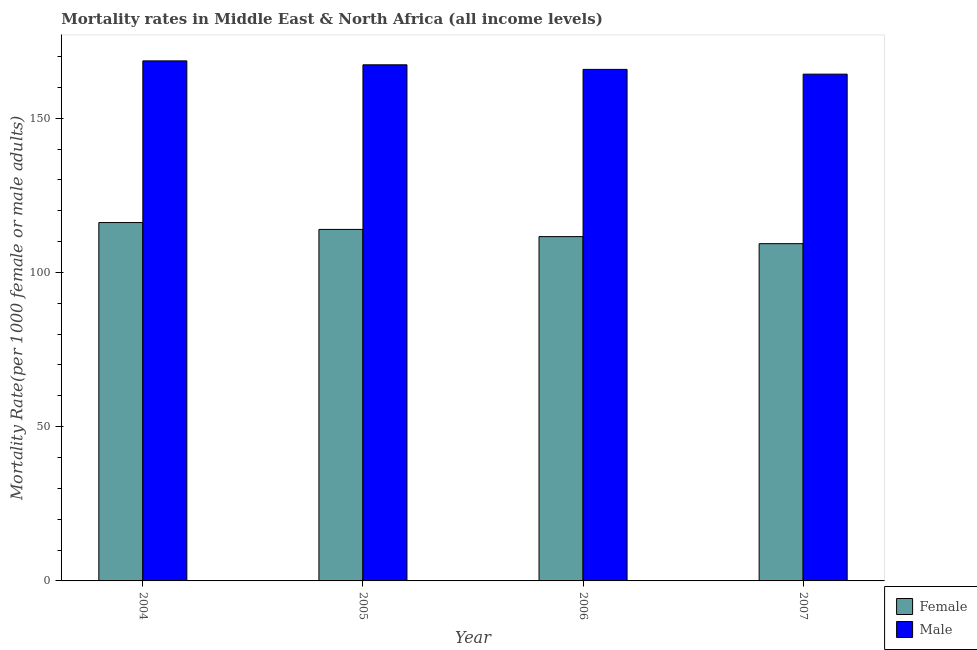How many bars are there on the 4th tick from the left?
Keep it short and to the point. 2. How many bars are there on the 3rd tick from the right?
Keep it short and to the point. 2. What is the male mortality rate in 2004?
Your answer should be compact. 168.58. Across all years, what is the maximum female mortality rate?
Make the answer very short. 116.17. Across all years, what is the minimum male mortality rate?
Offer a very short reply. 164.28. In which year was the female mortality rate maximum?
Provide a short and direct response. 2004. In which year was the male mortality rate minimum?
Your response must be concise. 2007. What is the total female mortality rate in the graph?
Your answer should be very brief. 451.04. What is the difference between the female mortality rate in 2004 and that in 2007?
Keep it short and to the point. 6.84. What is the difference between the male mortality rate in 2005 and the female mortality rate in 2004?
Keep it short and to the point. -1.27. What is the average female mortality rate per year?
Give a very brief answer. 112.76. In the year 2005, what is the difference between the female mortality rate and male mortality rate?
Your response must be concise. 0. In how many years, is the female mortality rate greater than 30?
Your answer should be compact. 4. What is the ratio of the female mortality rate in 2004 to that in 2005?
Make the answer very short. 1.02. Is the male mortality rate in 2005 less than that in 2007?
Ensure brevity in your answer.  No. Is the difference between the female mortality rate in 2005 and 2007 greater than the difference between the male mortality rate in 2005 and 2007?
Make the answer very short. No. What is the difference between the highest and the second highest female mortality rate?
Provide a succinct answer. 2.22. What is the difference between the highest and the lowest female mortality rate?
Your response must be concise. 6.84. Is the sum of the male mortality rate in 2006 and 2007 greater than the maximum female mortality rate across all years?
Make the answer very short. Yes. What does the 1st bar from the left in 2005 represents?
Your response must be concise. Female. What does the 1st bar from the right in 2006 represents?
Your answer should be compact. Male. How many bars are there?
Your response must be concise. 8. Are all the bars in the graph horizontal?
Provide a short and direct response. No. How many years are there in the graph?
Offer a terse response. 4. What is the difference between two consecutive major ticks on the Y-axis?
Offer a very short reply. 50. Are the values on the major ticks of Y-axis written in scientific E-notation?
Your answer should be very brief. No. Does the graph contain grids?
Keep it short and to the point. No. What is the title of the graph?
Offer a terse response. Mortality rates in Middle East & North Africa (all income levels). What is the label or title of the Y-axis?
Offer a terse response. Mortality Rate(per 1000 female or male adults). What is the Mortality Rate(per 1000 female or male adults) in Female in 2004?
Offer a terse response. 116.17. What is the Mortality Rate(per 1000 female or male adults) of Male in 2004?
Your answer should be compact. 168.58. What is the Mortality Rate(per 1000 female or male adults) in Female in 2005?
Offer a terse response. 113.94. What is the Mortality Rate(per 1000 female or male adults) in Male in 2005?
Offer a very short reply. 167.3. What is the Mortality Rate(per 1000 female or male adults) of Female in 2006?
Your answer should be compact. 111.61. What is the Mortality Rate(per 1000 female or male adults) in Male in 2006?
Your response must be concise. 165.82. What is the Mortality Rate(per 1000 female or male adults) in Female in 2007?
Give a very brief answer. 109.32. What is the Mortality Rate(per 1000 female or male adults) in Male in 2007?
Keep it short and to the point. 164.28. Across all years, what is the maximum Mortality Rate(per 1000 female or male adults) in Female?
Provide a short and direct response. 116.17. Across all years, what is the maximum Mortality Rate(per 1000 female or male adults) of Male?
Your response must be concise. 168.58. Across all years, what is the minimum Mortality Rate(per 1000 female or male adults) of Female?
Give a very brief answer. 109.32. Across all years, what is the minimum Mortality Rate(per 1000 female or male adults) in Male?
Your answer should be compact. 164.28. What is the total Mortality Rate(per 1000 female or male adults) of Female in the graph?
Your answer should be very brief. 451.04. What is the total Mortality Rate(per 1000 female or male adults) in Male in the graph?
Keep it short and to the point. 665.98. What is the difference between the Mortality Rate(per 1000 female or male adults) in Female in 2004 and that in 2005?
Give a very brief answer. 2.22. What is the difference between the Mortality Rate(per 1000 female or male adults) in Male in 2004 and that in 2005?
Your answer should be compact. 1.27. What is the difference between the Mortality Rate(per 1000 female or male adults) in Female in 2004 and that in 2006?
Ensure brevity in your answer.  4.56. What is the difference between the Mortality Rate(per 1000 female or male adults) of Male in 2004 and that in 2006?
Provide a short and direct response. 2.76. What is the difference between the Mortality Rate(per 1000 female or male adults) of Female in 2004 and that in 2007?
Your response must be concise. 6.84. What is the difference between the Mortality Rate(per 1000 female or male adults) of Male in 2004 and that in 2007?
Offer a very short reply. 4.3. What is the difference between the Mortality Rate(per 1000 female or male adults) of Female in 2005 and that in 2006?
Your answer should be compact. 2.33. What is the difference between the Mortality Rate(per 1000 female or male adults) of Male in 2005 and that in 2006?
Keep it short and to the point. 1.49. What is the difference between the Mortality Rate(per 1000 female or male adults) in Female in 2005 and that in 2007?
Your answer should be very brief. 4.62. What is the difference between the Mortality Rate(per 1000 female or male adults) in Male in 2005 and that in 2007?
Provide a succinct answer. 3.03. What is the difference between the Mortality Rate(per 1000 female or male adults) in Female in 2006 and that in 2007?
Your response must be concise. 2.29. What is the difference between the Mortality Rate(per 1000 female or male adults) in Male in 2006 and that in 2007?
Offer a very short reply. 1.54. What is the difference between the Mortality Rate(per 1000 female or male adults) in Female in 2004 and the Mortality Rate(per 1000 female or male adults) in Male in 2005?
Offer a very short reply. -51.14. What is the difference between the Mortality Rate(per 1000 female or male adults) in Female in 2004 and the Mortality Rate(per 1000 female or male adults) in Male in 2006?
Make the answer very short. -49.65. What is the difference between the Mortality Rate(per 1000 female or male adults) in Female in 2004 and the Mortality Rate(per 1000 female or male adults) in Male in 2007?
Offer a terse response. -48.11. What is the difference between the Mortality Rate(per 1000 female or male adults) of Female in 2005 and the Mortality Rate(per 1000 female or male adults) of Male in 2006?
Your answer should be very brief. -51.88. What is the difference between the Mortality Rate(per 1000 female or male adults) in Female in 2005 and the Mortality Rate(per 1000 female or male adults) in Male in 2007?
Keep it short and to the point. -50.33. What is the difference between the Mortality Rate(per 1000 female or male adults) of Female in 2006 and the Mortality Rate(per 1000 female or male adults) of Male in 2007?
Offer a terse response. -52.67. What is the average Mortality Rate(per 1000 female or male adults) of Female per year?
Offer a very short reply. 112.76. What is the average Mortality Rate(per 1000 female or male adults) in Male per year?
Provide a short and direct response. 166.49. In the year 2004, what is the difference between the Mortality Rate(per 1000 female or male adults) in Female and Mortality Rate(per 1000 female or male adults) in Male?
Ensure brevity in your answer.  -52.41. In the year 2005, what is the difference between the Mortality Rate(per 1000 female or male adults) of Female and Mortality Rate(per 1000 female or male adults) of Male?
Make the answer very short. -53.36. In the year 2006, what is the difference between the Mortality Rate(per 1000 female or male adults) in Female and Mortality Rate(per 1000 female or male adults) in Male?
Ensure brevity in your answer.  -54.21. In the year 2007, what is the difference between the Mortality Rate(per 1000 female or male adults) in Female and Mortality Rate(per 1000 female or male adults) in Male?
Your answer should be very brief. -54.95. What is the ratio of the Mortality Rate(per 1000 female or male adults) in Female in 2004 to that in 2005?
Your answer should be very brief. 1.02. What is the ratio of the Mortality Rate(per 1000 female or male adults) in Male in 2004 to that in 2005?
Your response must be concise. 1.01. What is the ratio of the Mortality Rate(per 1000 female or male adults) in Female in 2004 to that in 2006?
Your response must be concise. 1.04. What is the ratio of the Mortality Rate(per 1000 female or male adults) of Male in 2004 to that in 2006?
Offer a terse response. 1.02. What is the ratio of the Mortality Rate(per 1000 female or male adults) in Female in 2004 to that in 2007?
Your answer should be very brief. 1.06. What is the ratio of the Mortality Rate(per 1000 female or male adults) in Male in 2004 to that in 2007?
Your answer should be compact. 1.03. What is the ratio of the Mortality Rate(per 1000 female or male adults) of Female in 2005 to that in 2006?
Make the answer very short. 1.02. What is the ratio of the Mortality Rate(per 1000 female or male adults) in Female in 2005 to that in 2007?
Keep it short and to the point. 1.04. What is the ratio of the Mortality Rate(per 1000 female or male adults) of Male in 2005 to that in 2007?
Your answer should be compact. 1.02. What is the ratio of the Mortality Rate(per 1000 female or male adults) in Female in 2006 to that in 2007?
Your answer should be compact. 1.02. What is the ratio of the Mortality Rate(per 1000 female or male adults) of Male in 2006 to that in 2007?
Offer a terse response. 1.01. What is the difference between the highest and the second highest Mortality Rate(per 1000 female or male adults) of Female?
Keep it short and to the point. 2.22. What is the difference between the highest and the second highest Mortality Rate(per 1000 female or male adults) in Male?
Your answer should be very brief. 1.27. What is the difference between the highest and the lowest Mortality Rate(per 1000 female or male adults) of Female?
Ensure brevity in your answer.  6.84. What is the difference between the highest and the lowest Mortality Rate(per 1000 female or male adults) of Male?
Ensure brevity in your answer.  4.3. 